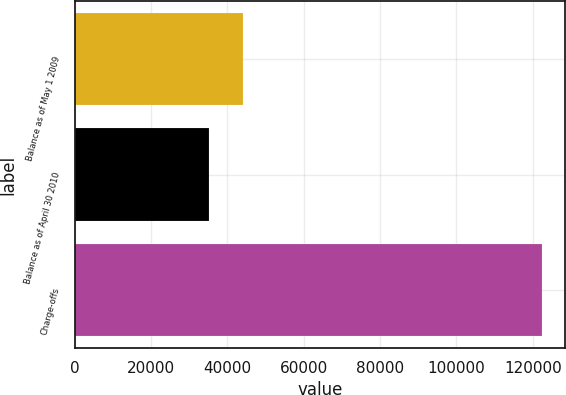Convert chart. <chart><loc_0><loc_0><loc_500><loc_500><bar_chart><fcel>Balance as of May 1 2009<fcel>Balance as of April 30 2010<fcel>Charge-offs<nl><fcel>43953.6<fcel>35239<fcel>122385<nl></chart> 